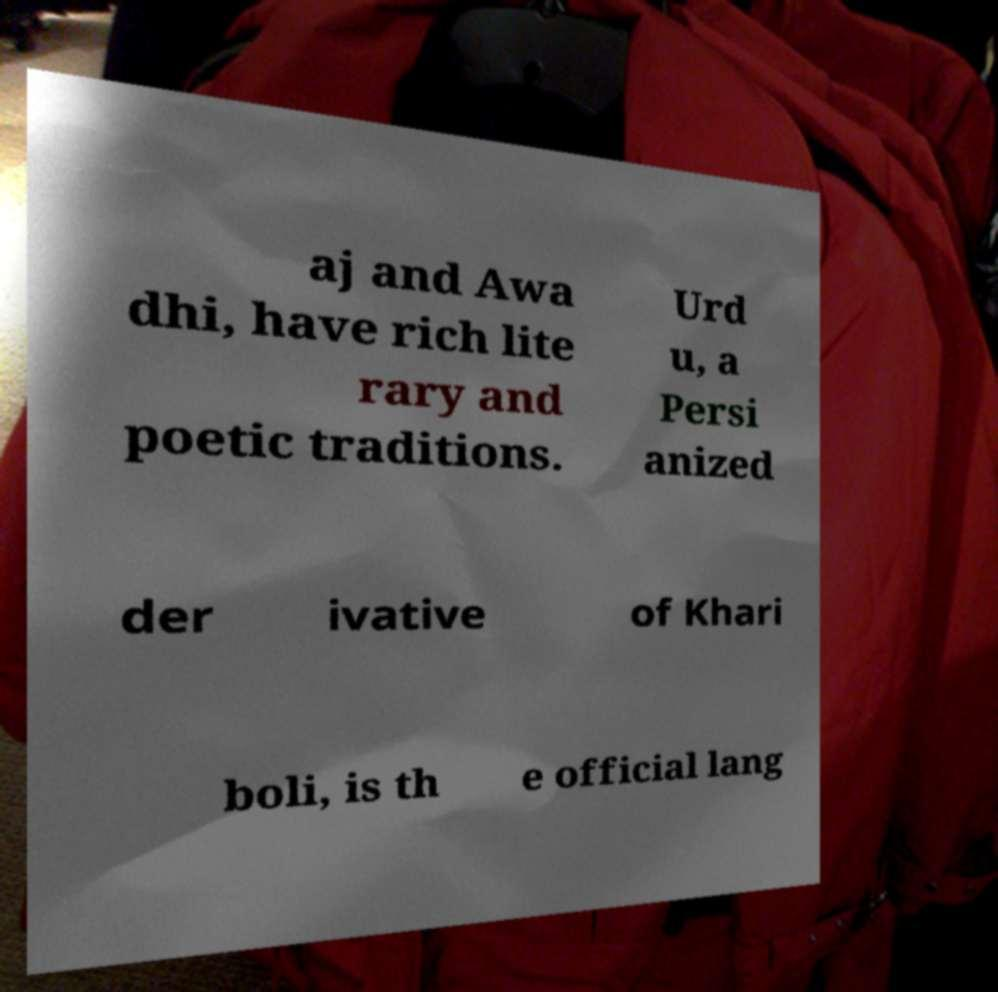Could you assist in decoding the text presented in this image and type it out clearly? aj and Awa dhi, have rich lite rary and poetic traditions. Urd u, a Persi anized der ivative of Khari boli, is th e official lang 